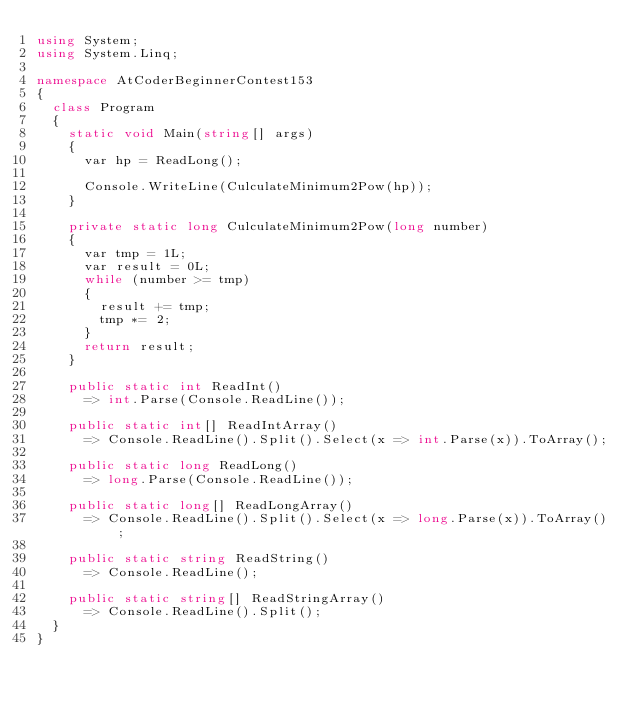Convert code to text. <code><loc_0><loc_0><loc_500><loc_500><_C#_>using System;
using System.Linq;

namespace AtCoderBeginnerContest153
{
	class Program
	{
		static void Main(string[] args)
		{
			var hp = ReadLong();

			Console.WriteLine(CulculateMinimum2Pow(hp));
		}

		private static long CulculateMinimum2Pow(long number)
		{
			var tmp = 1L;
			var result = 0L;
			while (number >= tmp)
			{
				result += tmp;
				tmp *= 2;
			}
			return result;
		}

		public static int ReadInt()
			=> int.Parse(Console.ReadLine());

		public static int[] ReadIntArray()
			=> Console.ReadLine().Split().Select(x => int.Parse(x)).ToArray();

		public static long ReadLong()
			=> long.Parse(Console.ReadLine());

		public static long[] ReadLongArray()
			=> Console.ReadLine().Split().Select(x => long.Parse(x)).ToArray();

		public static string ReadString()
			=> Console.ReadLine();

		public static string[] ReadStringArray()
			=> Console.ReadLine().Split();
	}
}
</code> 